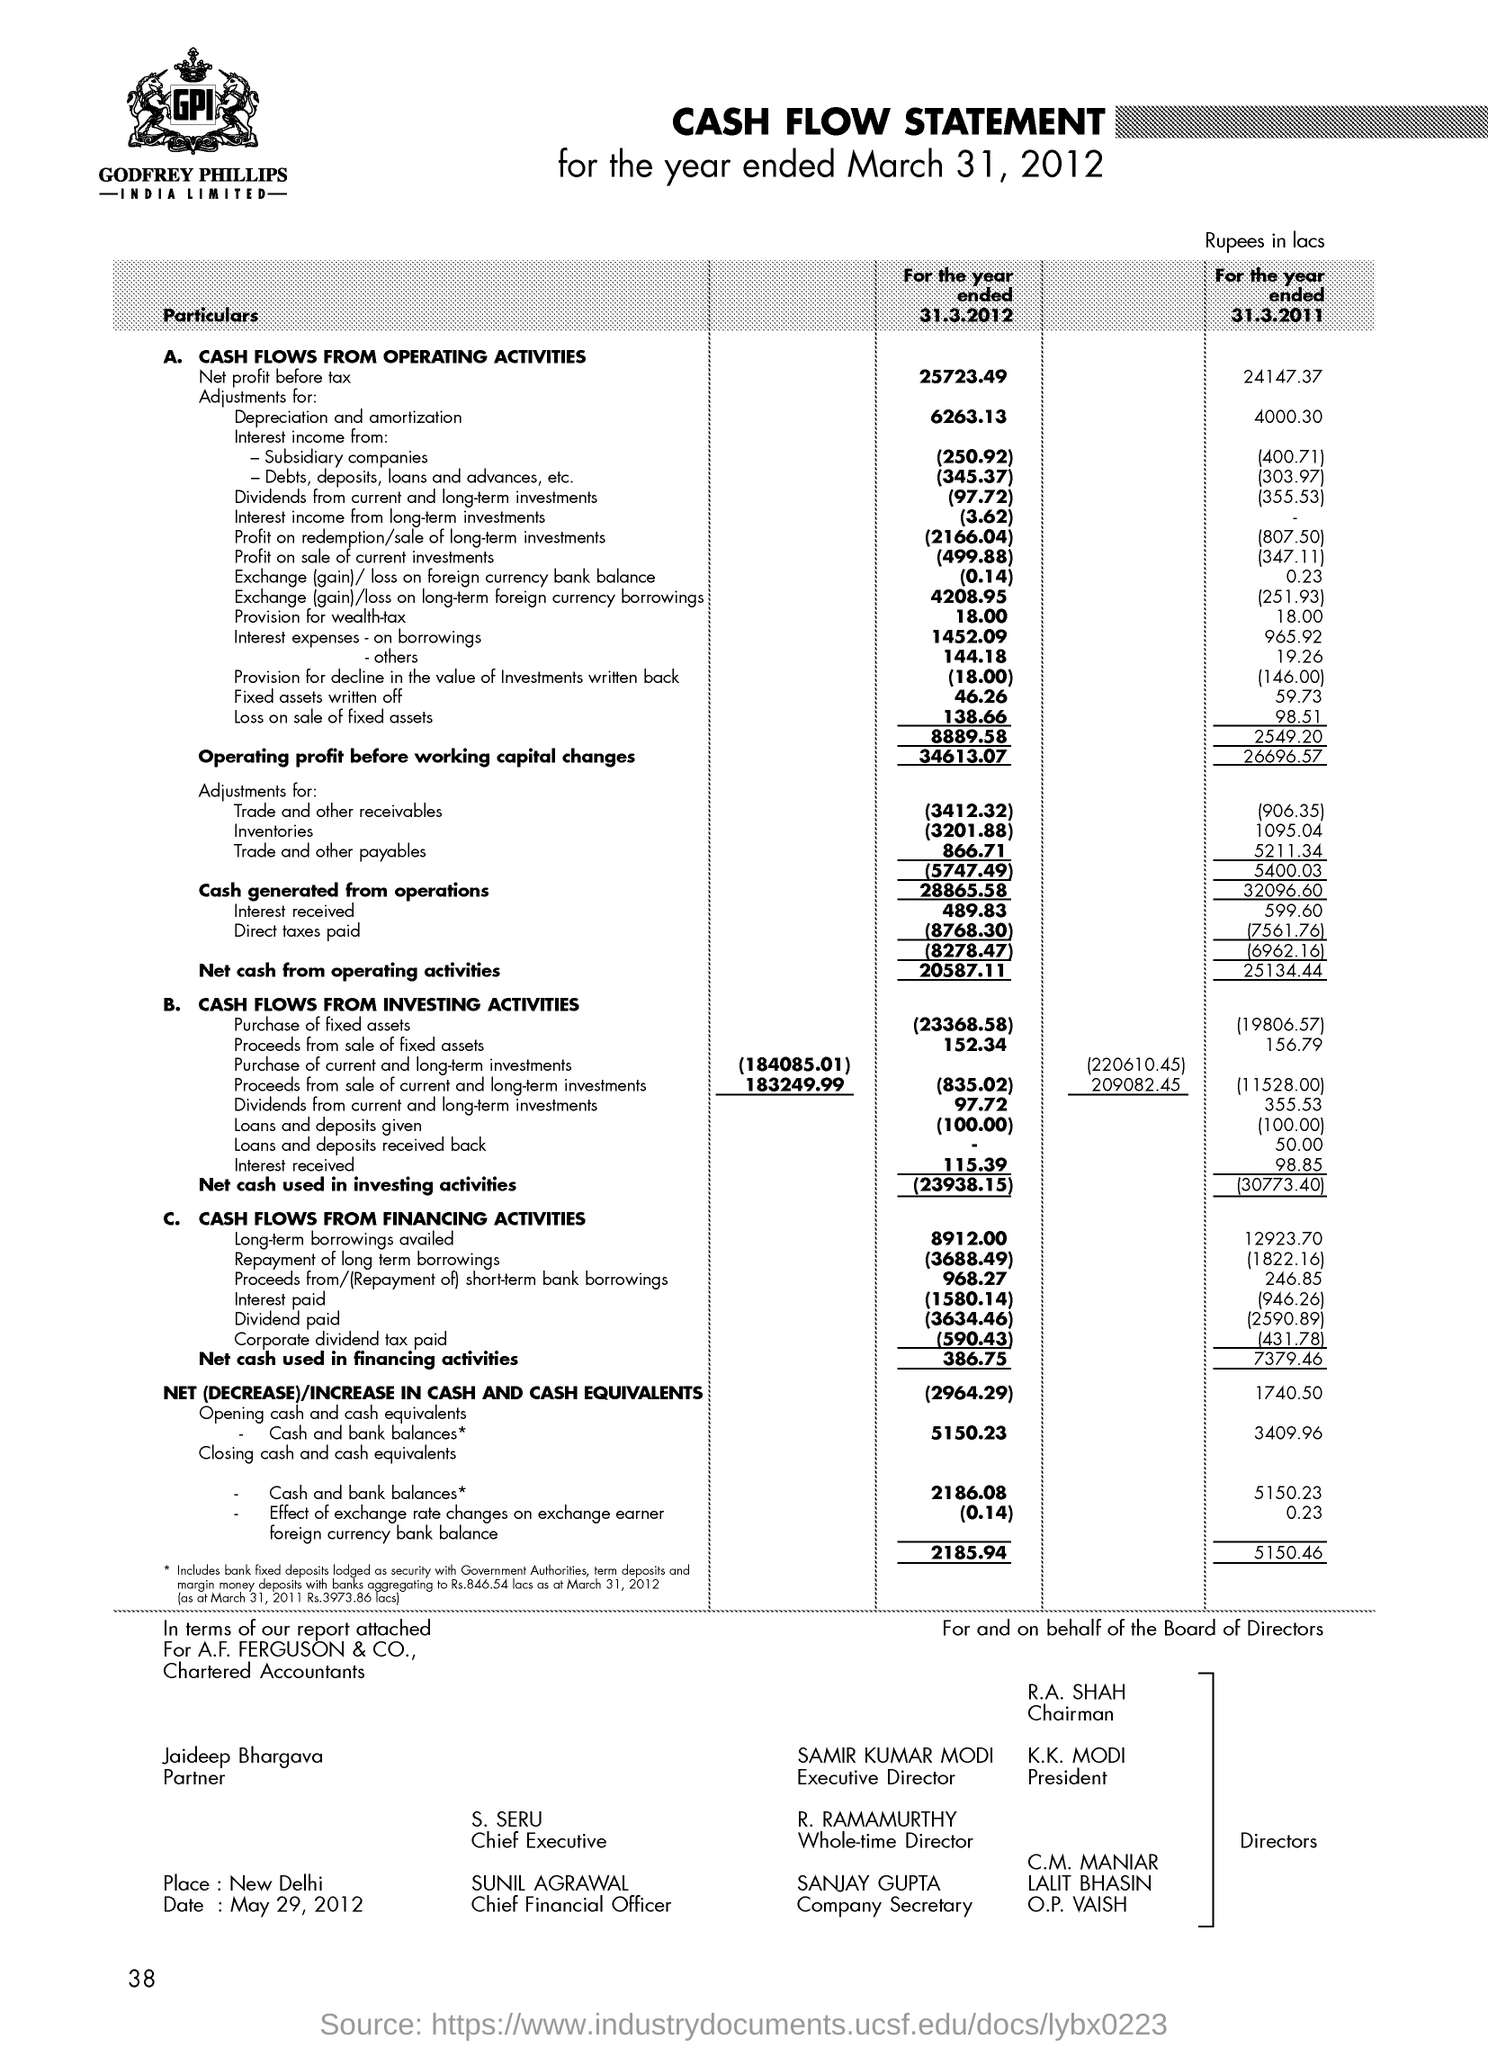Highlight a few significant elements in this photo. The value of trade and other payables for the year ended March 31, 2012, was $866.71. Sunil Agrarawal is the Chief Financial Officer. 